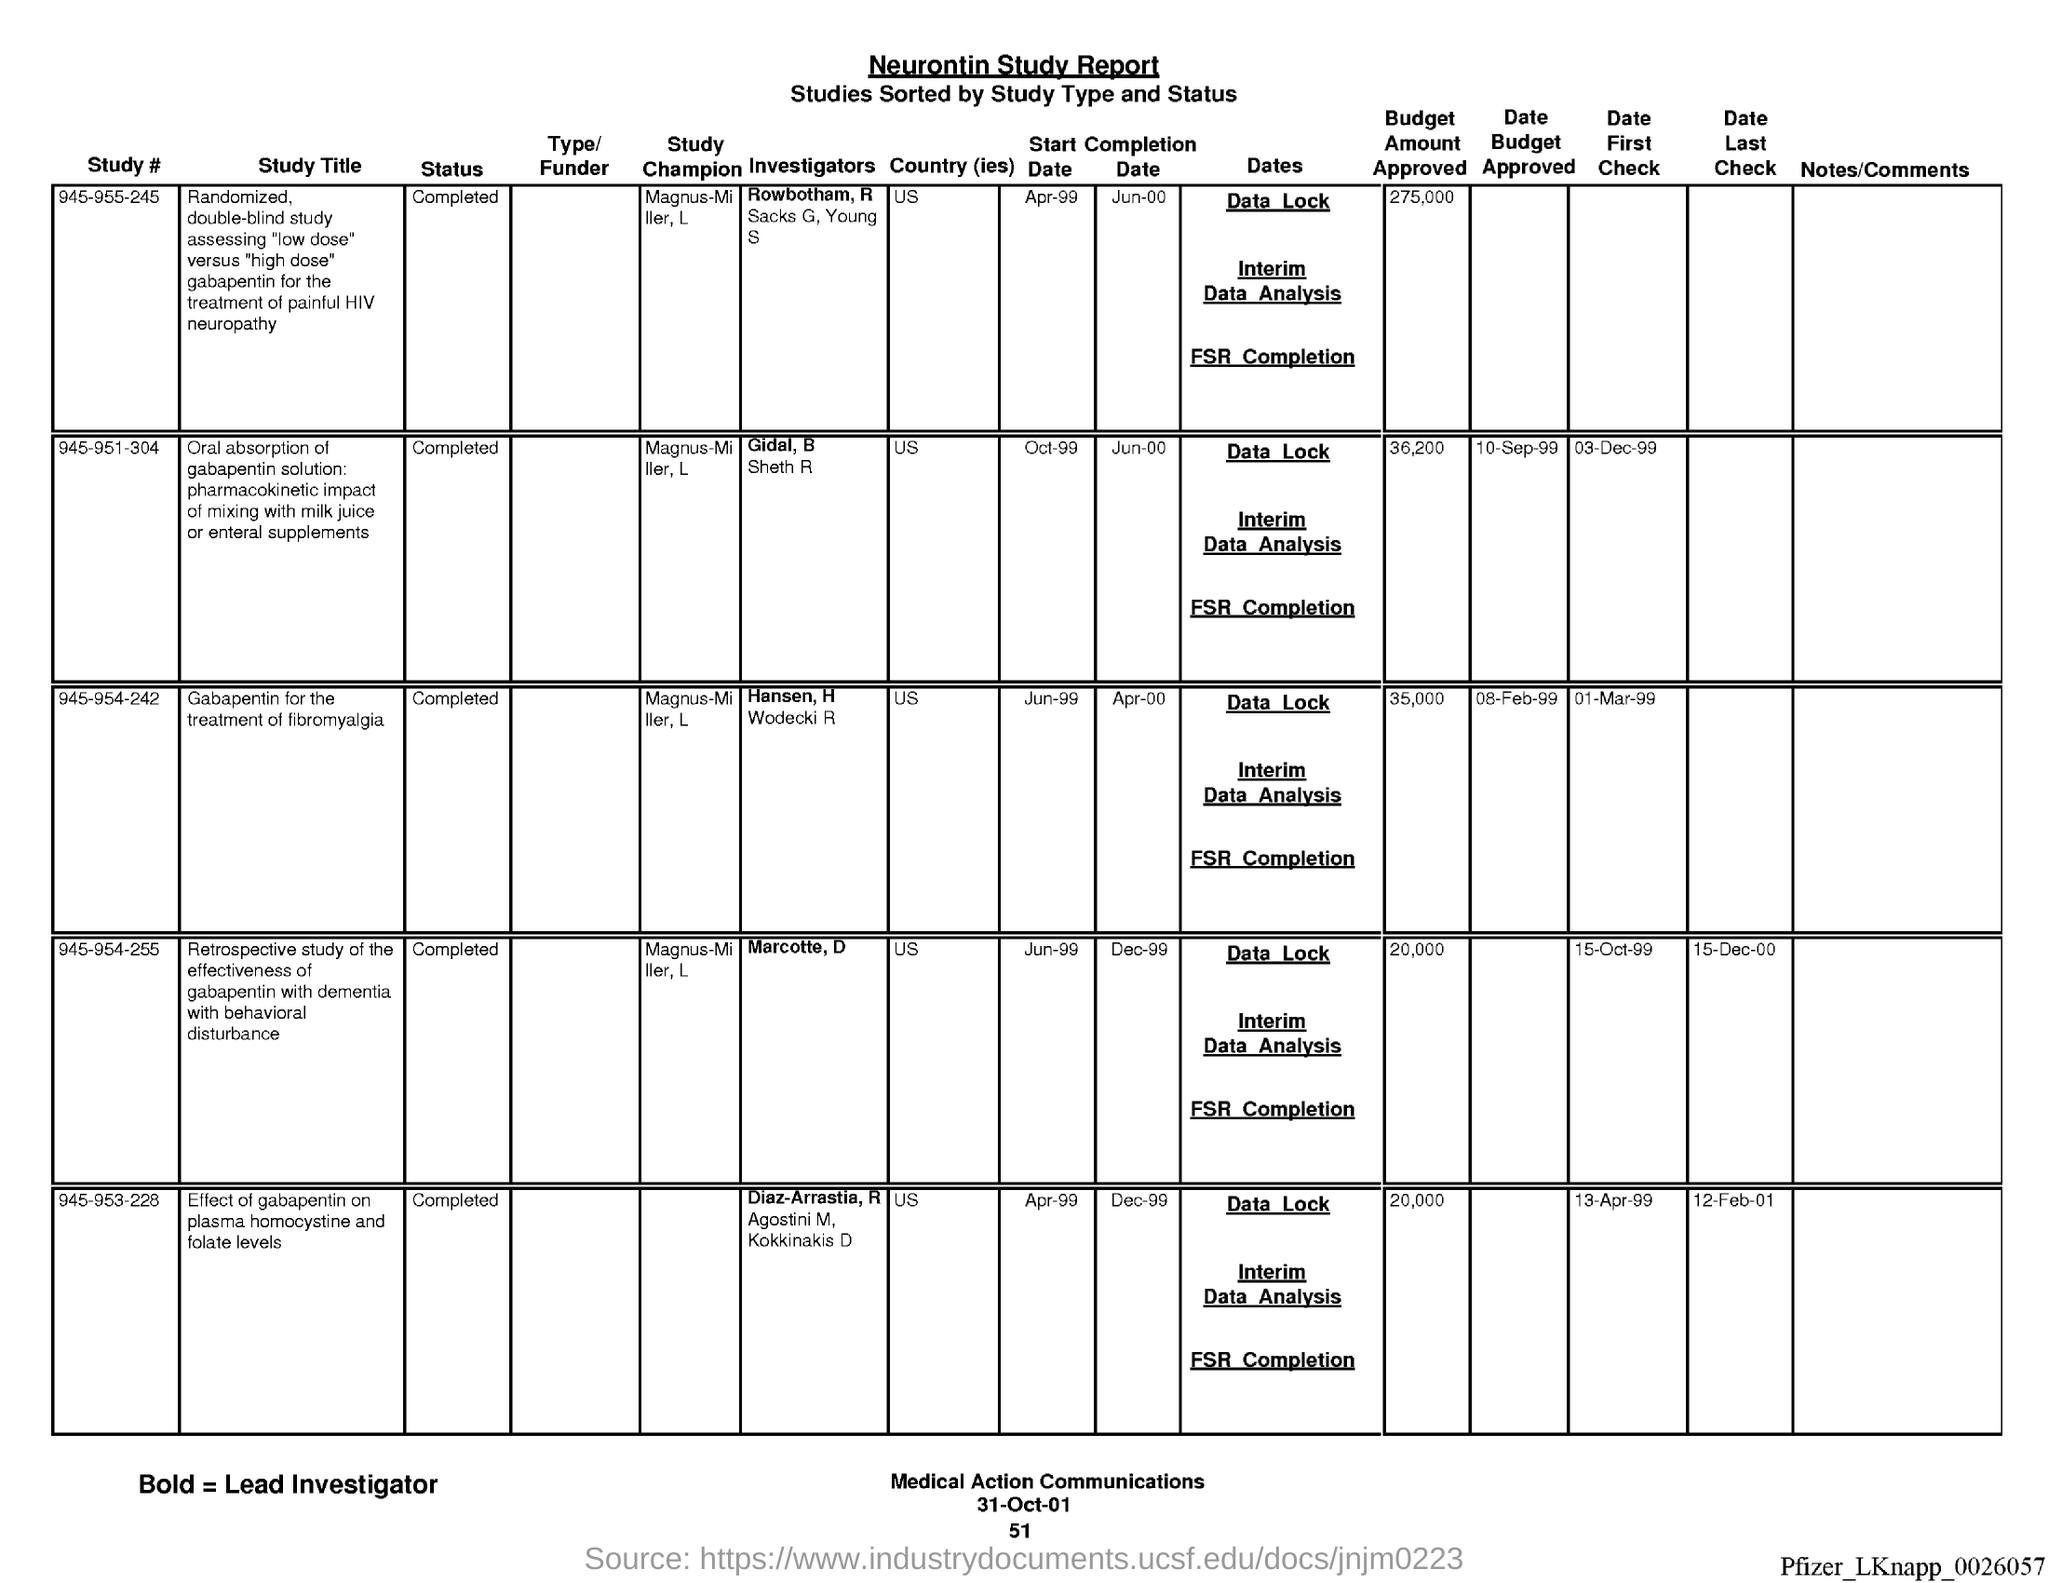Identify some key points in this picture. The date at the bottom of the page is 31-Oct-01. The Neurontin Study report is commonly referred to as the 'Neurontin Study report.' The page number below the date is 51. 